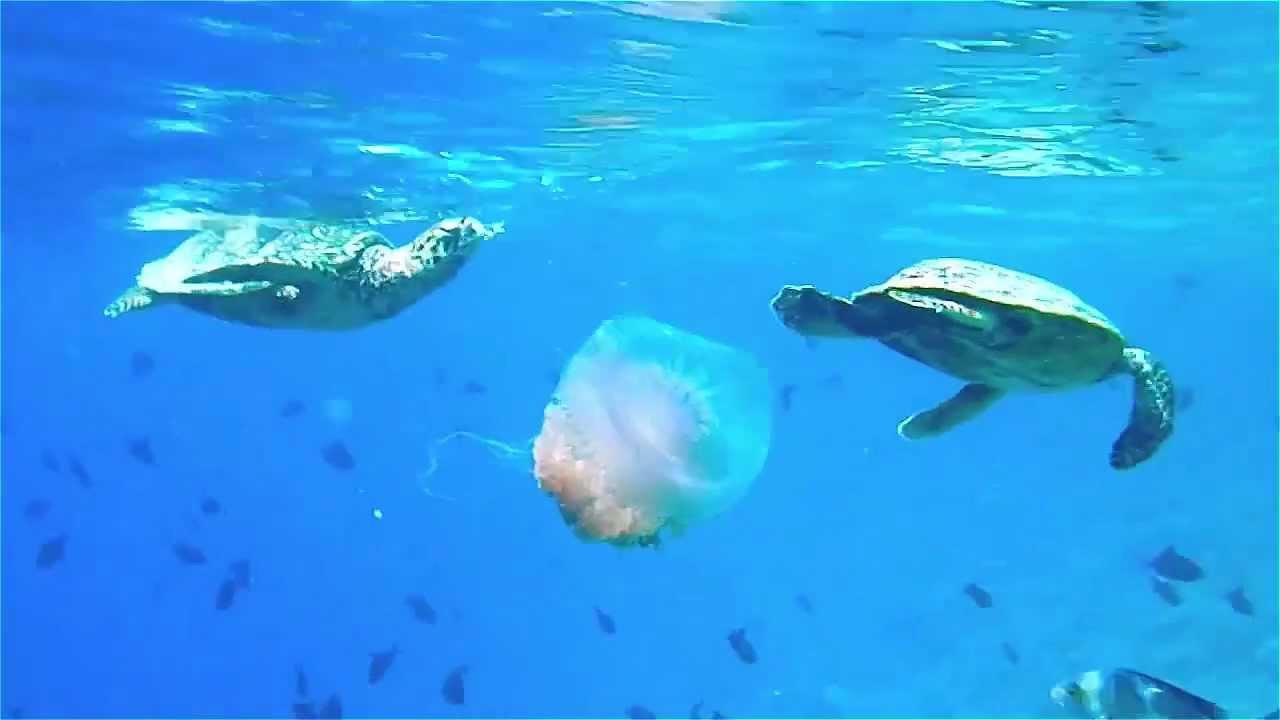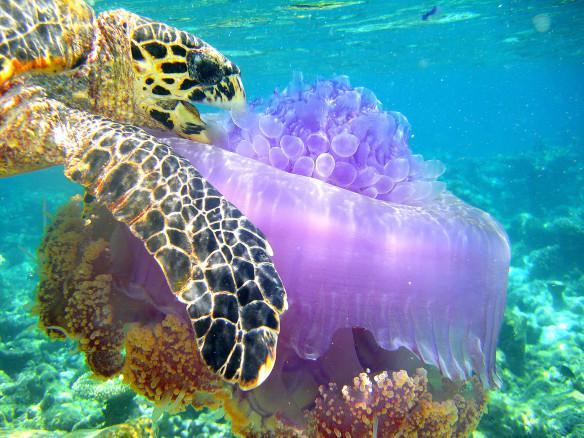The first image is the image on the left, the second image is the image on the right. Assess this claim about the two images: "There are no more than six fish swimming next to a turtle.". Correct or not? Answer yes or no. No. The first image is the image on the left, the second image is the image on the right. Given the left and right images, does the statement "a turtle is taking a bite of a pink jellyfish" hold true? Answer yes or no. Yes. 